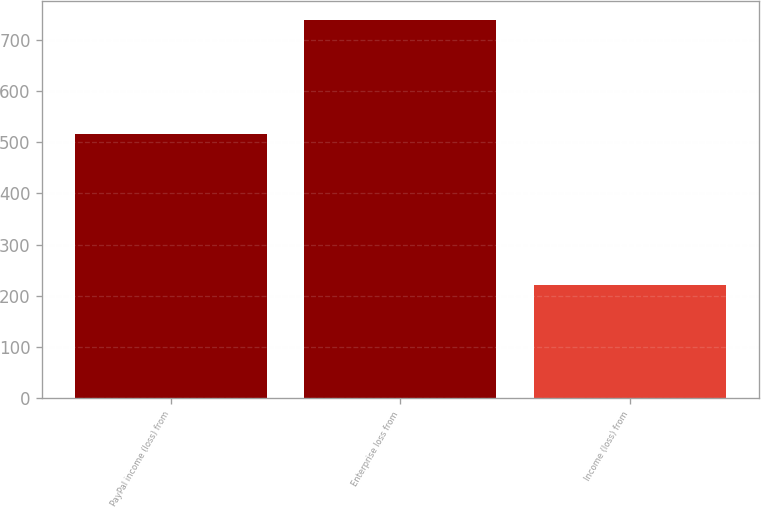<chart> <loc_0><loc_0><loc_500><loc_500><bar_chart><fcel>PayPal income (loss) from<fcel>Enterprise loss from<fcel>Income (loss) from<nl><fcel>516<fcel>738<fcel>222<nl></chart> 